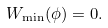<formula> <loc_0><loc_0><loc_500><loc_500>W _ { \min } ( \phi ) = 0 .</formula> 